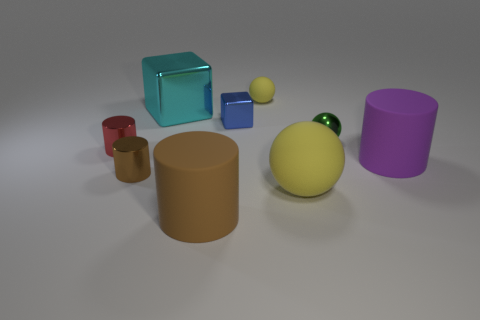There is a ball that is in front of the purple matte cylinder; what is its size?
Ensure brevity in your answer.  Large. Is the number of green balls behind the green metallic object less than the number of blue metallic things on the left side of the small yellow object?
Provide a succinct answer. Yes. What material is the cylinder that is both on the right side of the big cyan metallic object and behind the big brown matte object?
Your answer should be very brief. Rubber. What is the shape of the tiny metal object in front of the large matte cylinder that is right of the blue shiny object?
Your answer should be compact. Cylinder. Do the metal sphere and the small rubber ball have the same color?
Provide a succinct answer. No. What number of purple things are either small blocks or large cylinders?
Offer a very short reply. 1. Are there any cyan things on the left side of the brown metallic cylinder?
Make the answer very short. No. What is the size of the brown metallic object?
Provide a short and direct response. Small. The red thing that is the same shape as the big purple object is what size?
Offer a very short reply. Small. How many purple rubber objects are behind the block that is in front of the big cyan object?
Make the answer very short. 0. 